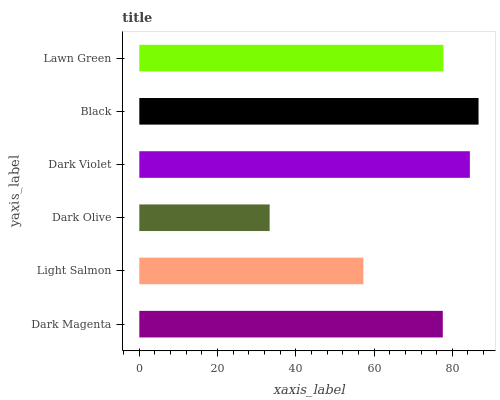Is Dark Olive the minimum?
Answer yes or no. Yes. Is Black the maximum?
Answer yes or no. Yes. Is Light Salmon the minimum?
Answer yes or no. No. Is Light Salmon the maximum?
Answer yes or no. No. Is Dark Magenta greater than Light Salmon?
Answer yes or no. Yes. Is Light Salmon less than Dark Magenta?
Answer yes or no. Yes. Is Light Salmon greater than Dark Magenta?
Answer yes or no. No. Is Dark Magenta less than Light Salmon?
Answer yes or no. No. Is Lawn Green the high median?
Answer yes or no. Yes. Is Dark Magenta the low median?
Answer yes or no. Yes. Is Black the high median?
Answer yes or no. No. Is Lawn Green the low median?
Answer yes or no. No. 